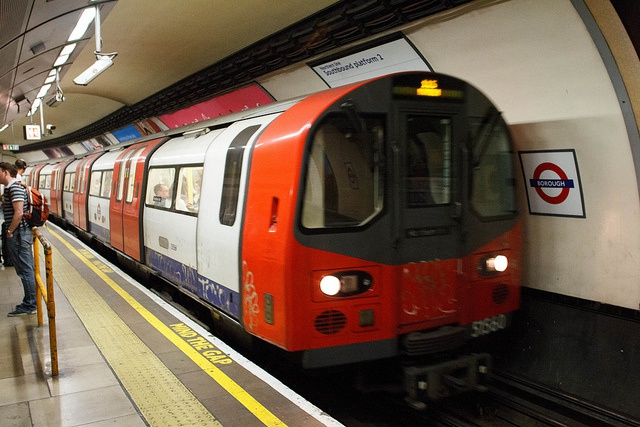Describe the objects in this image and their specific colors. I can see train in black, maroon, and lightgray tones, people in black, gray, and maroon tones, backpack in black, maroon, and gray tones, people in black, darkgray, tan, and gray tones, and people in black, white, and gray tones in this image. 